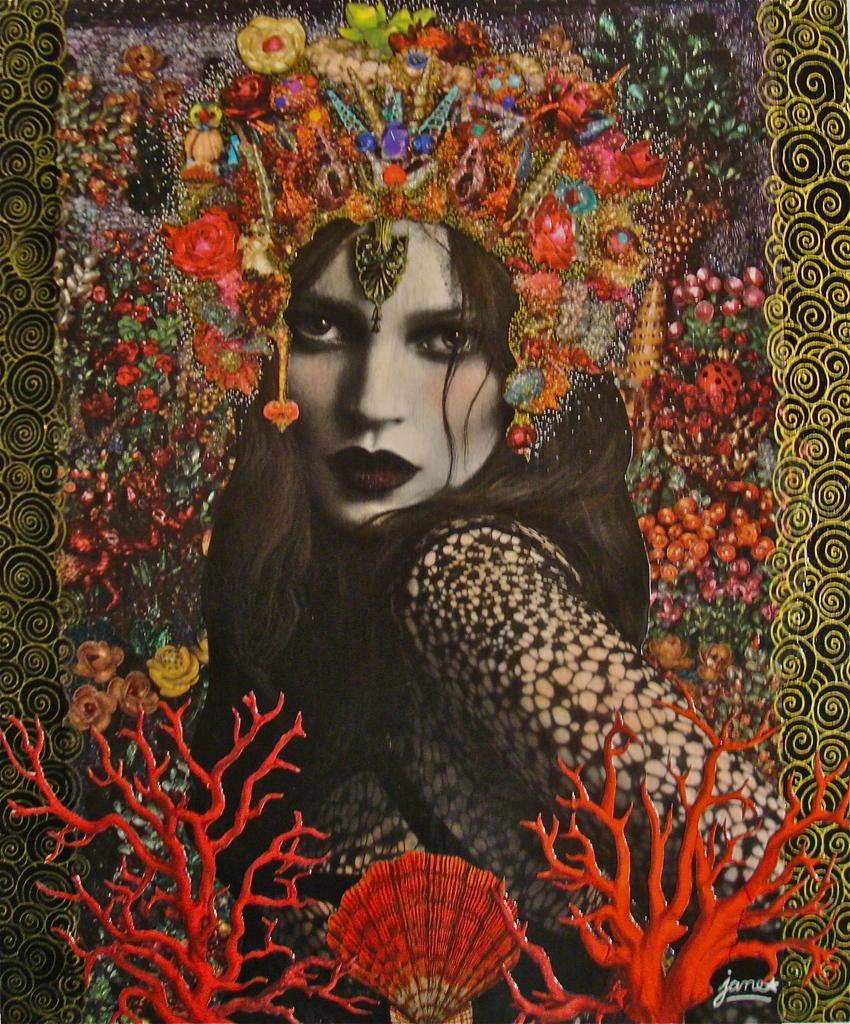What can be said about the nature of the image? The image is edited. Who is present in the image? There is a woman in the image. What is the woman wearing? The woman is wearing a crown. Where is the woman positioned in the image? The woman is at the center of the image. Can you see a gun in the woman's hand in the image? No, there is no gun present in the image. What type of toothbrush is the woman using in the image? There is no toothbrush present in the image. 